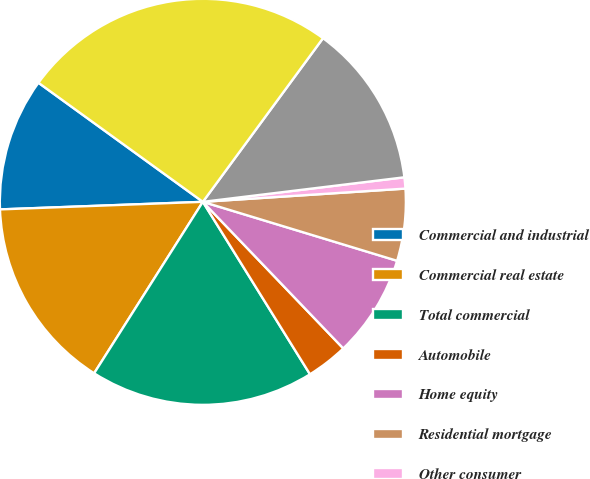<chart> <loc_0><loc_0><loc_500><loc_500><pie_chart><fcel>Commercial and industrial<fcel>Commercial real estate<fcel>Total commercial<fcel>Automobile<fcel>Home equity<fcel>Residential mortgage<fcel>Other consumer<fcel>Total consumer<fcel>Total ALLL<nl><fcel>10.57%<fcel>15.41%<fcel>17.84%<fcel>3.31%<fcel>8.15%<fcel>5.73%<fcel>0.89%<fcel>12.99%<fcel>25.1%<nl></chart> 